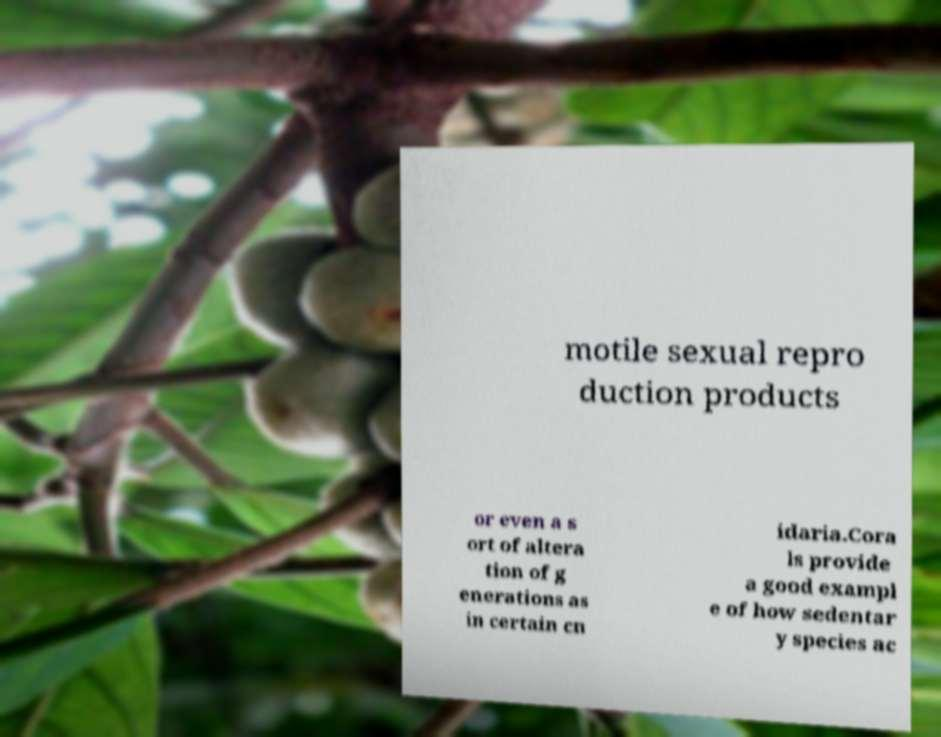I need the written content from this picture converted into text. Can you do that? motile sexual repro duction products or even a s ort of altera tion of g enerations as in certain cn idaria.Cora ls provide a good exampl e of how sedentar y species ac 